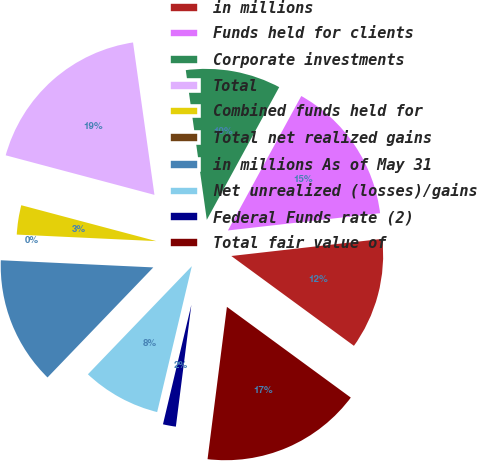Convert chart to OTSL. <chart><loc_0><loc_0><loc_500><loc_500><pie_chart><fcel>in millions<fcel>Funds held for clients<fcel>Corporate investments<fcel>Total<fcel>Combined funds held for<fcel>Total net realized gains<fcel>in millions As of May 31<fcel>Net unrealized (losses)/gains<fcel>Federal Funds rate (2)<fcel>Total fair value of<nl><fcel>11.86%<fcel>15.25%<fcel>10.17%<fcel>18.64%<fcel>3.39%<fcel>0.0%<fcel>13.56%<fcel>8.47%<fcel>1.7%<fcel>16.95%<nl></chart> 